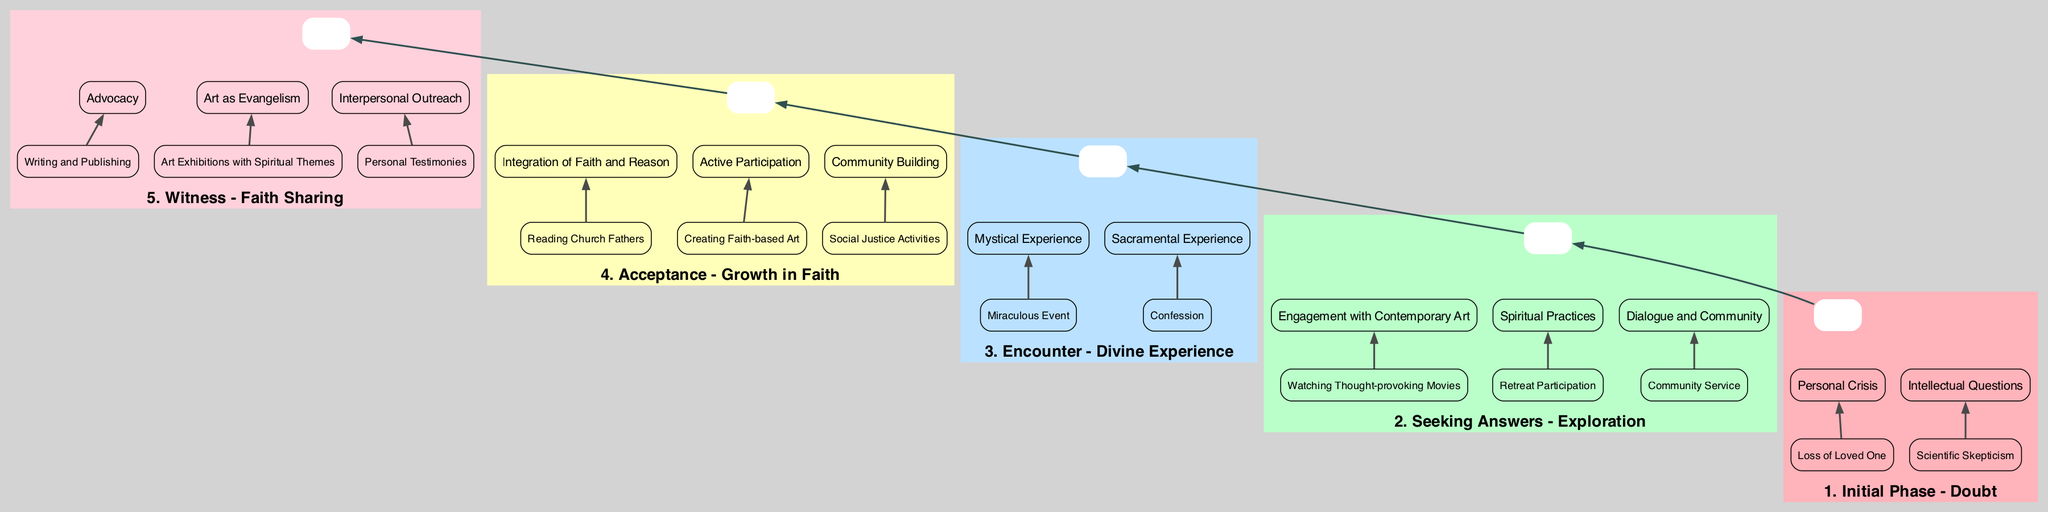What is the first phase of the journey? The diagram shows that the first phase is "Initial Phase - Doubt". This is identified at the bottom of the flow and is the starting point of the diagram.
Answer: Initial Phase - Doubt How many elements are there in the "Seeking Answers - Exploration" phase? In the phase "Seeking Answers - Exploration", there are three elements listed: Engagement with Contemporary Art, Spiritual Practices, and Dialogue and Community. Counting these gives a total of three.
Answer: 3 Which phase follows "Encounter - Divine Experience"? The flow of the diagram connects the phases in a bottom-to-up manner, indicating that "Acceptance - Growth in Faith" directly follows "Encounter - Divine Experience". Hence, the answer is found by identifying the phase directly above it.
Answer: Acceptance - Growth in Faith What is one of the entities listed under "Personal Crisis"? Under the "Personal Crisis" element for the "Initial Phase - Doubt", one of the entities provided is "Loss of Loved One". It's distinctly listed among other entities and can be directly referenced.
Answer: Loss of Loved One How does "Art as Evangelism" appear in the final phase? In the "Witness - Faith Sharing" phase, "Art as Evangelism" is one of the listed elements. It illustrates the concept of using art to share faith, signifying its presence in the last phase of the diagram.
Answer: Art as Evangelism What is the relationship between "Eucharist" and "Encounter - Divine Experience"? "Eucharist" is categorized under the "Sacramental Experience" element in the "Encounter - Divine Experience" phase. It thereby establishes a direct relationship, as both belong to the same phase.
Answer: Sacramental Experience Which are the two entities listed under "Active Participation"? The "Active Participation" element under the "Acceptance - Growth in Faith" phase contains two entities: "Leading Prayer Groups" and "Creating Faith-based Art". These can be found as entities within that specific element.
Answer: Leading Prayer Groups, Creating Faith-based Art What is the last phase shown in the diagram? Looking at the top of the flow diagram, the last phase listed is "Witness - Faith Sharing". This can be verified visually as the final node in the upward flow.
Answer: Witness - Faith Sharing What transitions the flow from "Acceptance - Growth in Faith" to "Witness - Faith Sharing"? The flow connects the "Acceptance - Growth in Faith" phase to the "Witness - Faith Sharing" phase with a bold edge, indicating that this is the next progression in the spiritual journey.
Answer: Bold edge 